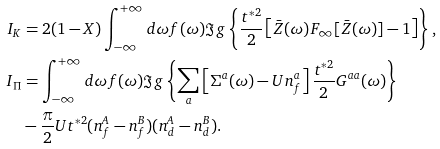Convert formula to latex. <formula><loc_0><loc_0><loc_500><loc_500>I _ { K } & = 2 ( 1 - X ) \int _ { - \infty } ^ { + \infty } d \omega f ( \omega ) \Im g \left \{ \frac { t ^ { * 2 } } { 2 } \left [ \bar { Z } ( \omega ) F _ { \infty } [ \bar { Z } ( \omega ) ] - 1 \right ] \right \} , \\ I _ { \Pi } & = \int _ { - \infty } ^ { + \infty } d \omega f ( \omega ) \Im g \left \{ \sum _ { a } \left [ \Sigma ^ { a } ( \omega ) - U n _ { f } ^ { a } \right ] \frac { t ^ { * 2 } } { 2 } G ^ { a a } ( \omega ) \right \} \\ & - \frac { \pi } { 2 } U t ^ { * 2 } ( n _ { f } ^ { A } - n _ { f } ^ { B } ) ( n _ { d } ^ { A } - n _ { d } ^ { B } ) .</formula> 